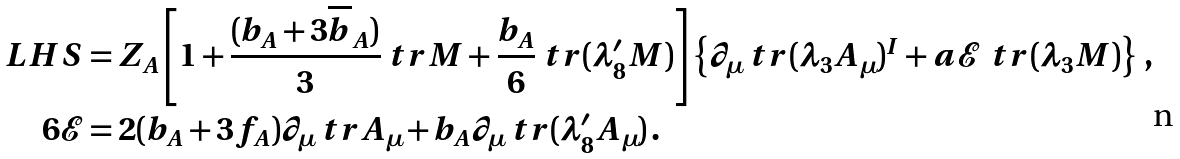<formula> <loc_0><loc_0><loc_500><loc_500>L H S & = Z _ { A } \left [ 1 + \frac { ( b _ { A } + 3 \overline { b } _ { A } ) } { 3 } \ t r M + \frac { b _ { A } } { 6 } \ t r ( \lambda ^ { \prime } _ { 8 } M ) \right ] \left \{ \partial _ { \mu } \ t r ( \lambda _ { 3 } A _ { \mu } ) ^ { I } + a \mathcal { E } \, \ t r ( \lambda _ { 3 } M ) \right \} \, , \\ 6 \mathcal { E } & = 2 ( b _ { A } + 3 f _ { A } ) \partial _ { \mu } \ t r A _ { \mu } + b _ { A } \partial _ { \mu } \ t r ( \lambda ^ { \prime } _ { 8 } A _ { \mu } ) \, .</formula> 